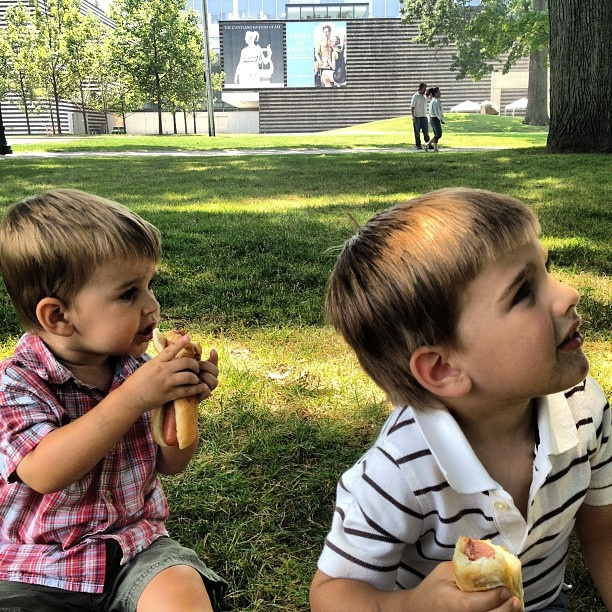Describe the objects in this image and their specific colors. I can see people in white, black, lightgray, gray, and maroon tones, people in white, black, maroon, brown, and tan tones, sandwich in white, khaki, tan, and olive tones, hot dog in white, brown, maroon, tan, and khaki tones, and hot dog in white, tan, khaki, and olive tones in this image. 